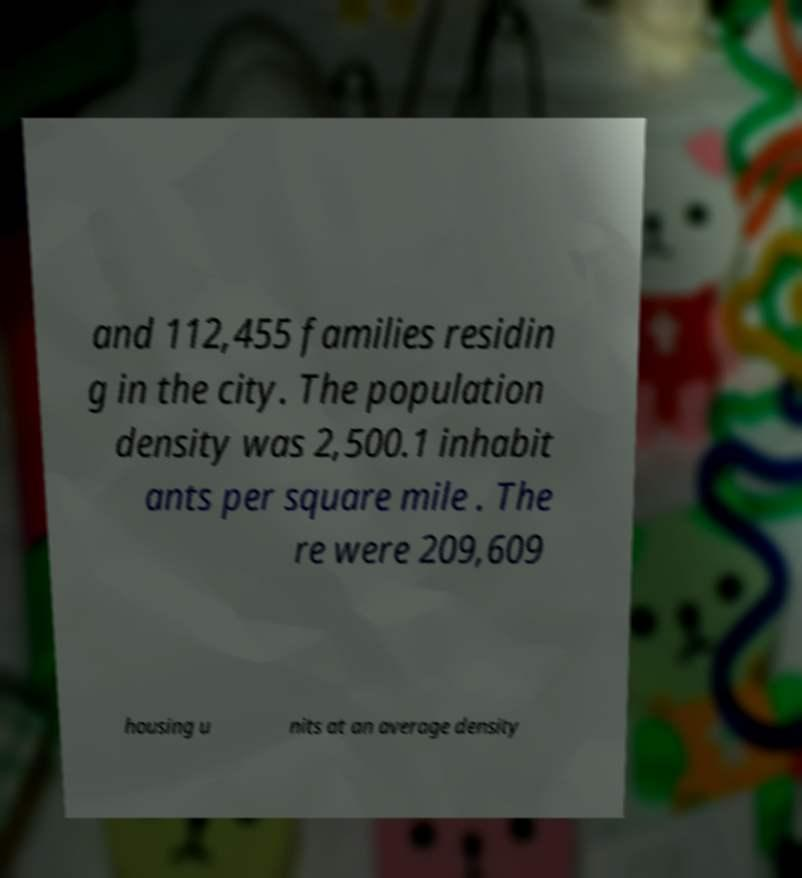Please read and relay the text visible in this image. What does it say? and 112,455 families residin g in the city. The population density was 2,500.1 inhabit ants per square mile . The re were 209,609 housing u nits at an average density 